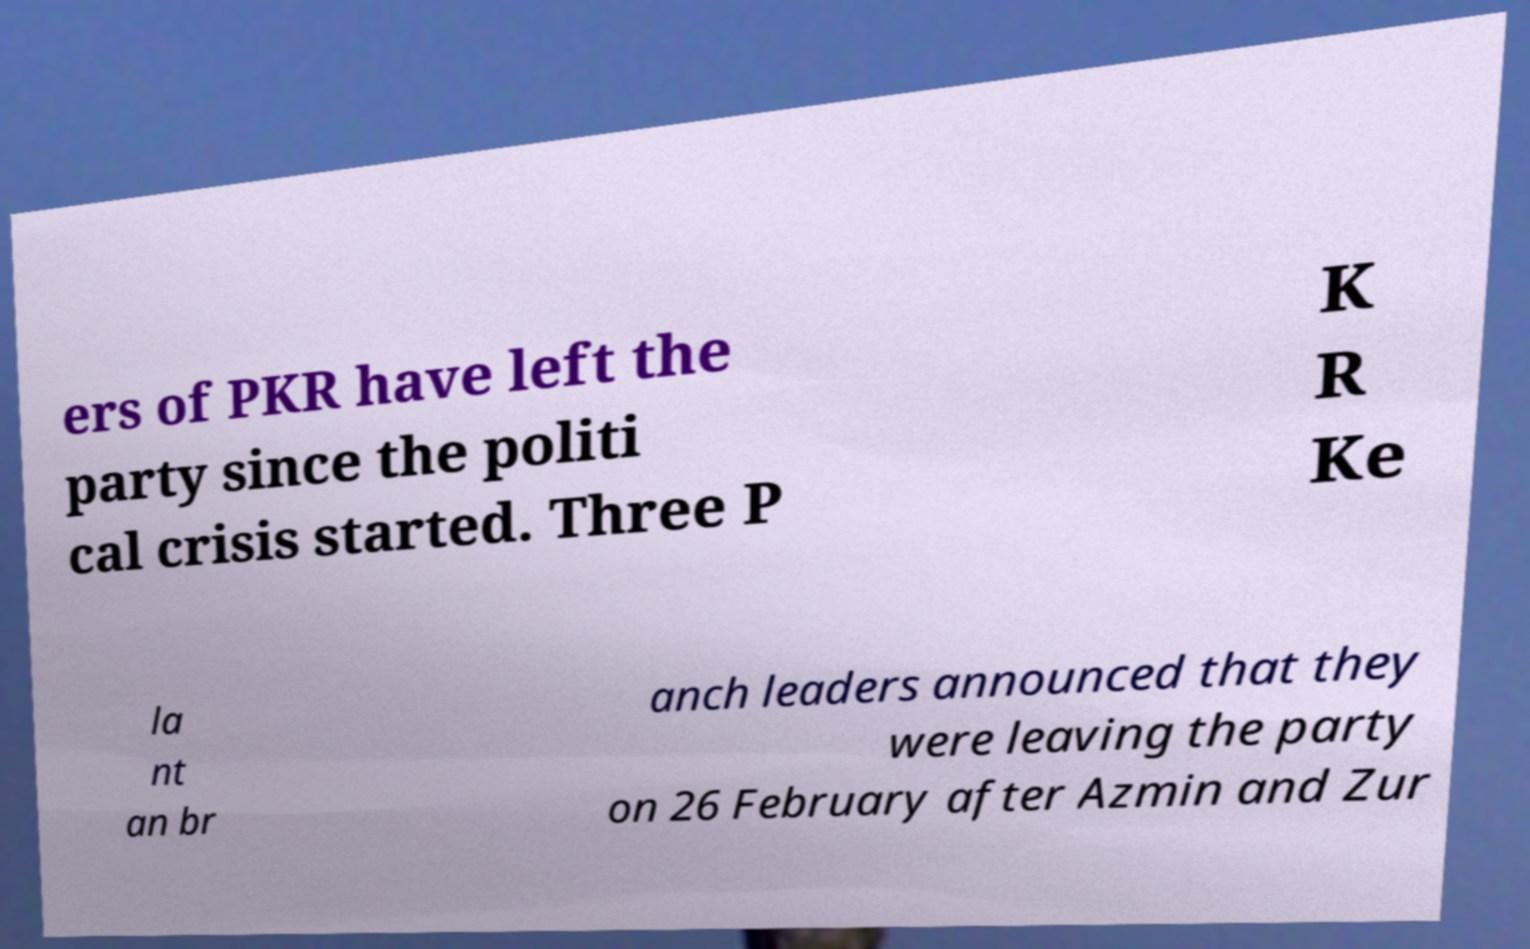Please read and relay the text visible in this image. What does it say? ers of PKR have left the party since the politi cal crisis started. Three P K R Ke la nt an br anch leaders announced that they were leaving the party on 26 February after Azmin and Zur 